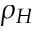<formula> <loc_0><loc_0><loc_500><loc_500>\rho _ { H }</formula> 